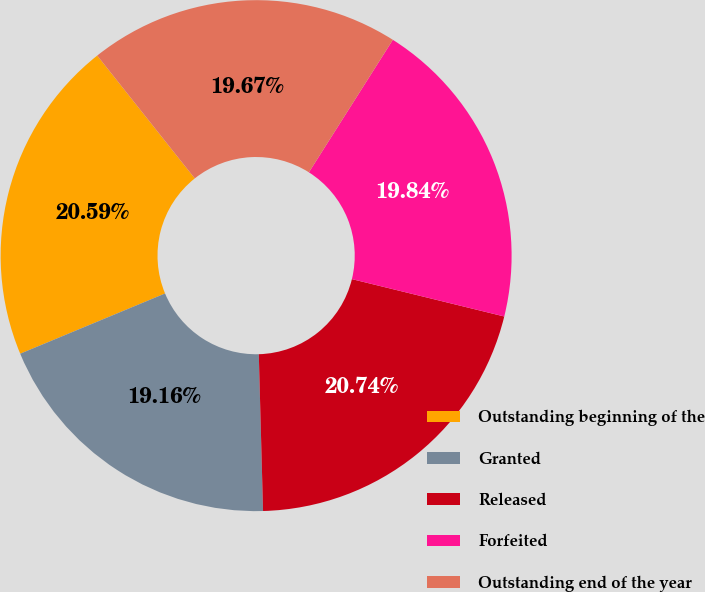Convert chart. <chart><loc_0><loc_0><loc_500><loc_500><pie_chart><fcel>Outstanding beginning of the<fcel>Granted<fcel>Released<fcel>Forfeited<fcel>Outstanding end of the year<nl><fcel>20.59%<fcel>19.16%<fcel>20.74%<fcel>19.84%<fcel>19.67%<nl></chart> 